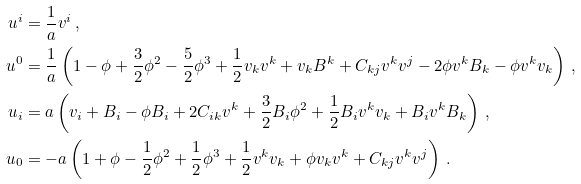Convert formula to latex. <formula><loc_0><loc_0><loc_500><loc_500>u ^ { i } & = \frac { 1 } { a } v ^ { i } \, , \\ u ^ { 0 } & = \frac { 1 } { a } \left ( 1 - \phi + \frac { 3 } { 2 } \phi ^ { 2 } - \frac { 5 } { 2 } \phi ^ { 3 } + \frac { 1 } { 2 } v _ { k } v ^ { k } + v _ { k } B ^ { k } + C _ { k j } v ^ { k } v ^ { j } - 2 \phi v ^ { k } B _ { k } - \phi v ^ { k } v _ { k } \right ) \, , \\ u _ { i } & = a \left ( v _ { i } + B _ { i } - \phi B _ { i } + 2 C _ { i k } v ^ { k } + \frac { 3 } { 2 } B _ { i } \phi ^ { 2 } + \frac { 1 } { 2 } B _ { i } v ^ { k } v _ { k } + B _ { i } v ^ { k } B _ { k } \right ) \, , \\ u _ { 0 } & = - a \left ( 1 + \phi - \frac { 1 } { 2 } \phi ^ { 2 } + \frac { 1 } { 2 } \phi ^ { 3 } + \frac { 1 } { 2 } v ^ { k } v _ { k } + \phi v _ { k } v ^ { k } + C _ { k j } v ^ { k } v ^ { j } \right ) \, .</formula> 